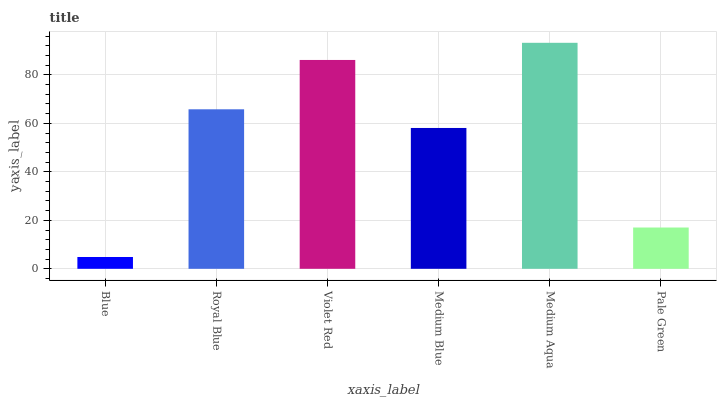Is Blue the minimum?
Answer yes or no. Yes. Is Medium Aqua the maximum?
Answer yes or no. Yes. Is Royal Blue the minimum?
Answer yes or no. No. Is Royal Blue the maximum?
Answer yes or no. No. Is Royal Blue greater than Blue?
Answer yes or no. Yes. Is Blue less than Royal Blue?
Answer yes or no. Yes. Is Blue greater than Royal Blue?
Answer yes or no. No. Is Royal Blue less than Blue?
Answer yes or no. No. Is Royal Blue the high median?
Answer yes or no. Yes. Is Medium Blue the low median?
Answer yes or no. Yes. Is Blue the high median?
Answer yes or no. No. Is Violet Red the low median?
Answer yes or no. No. 